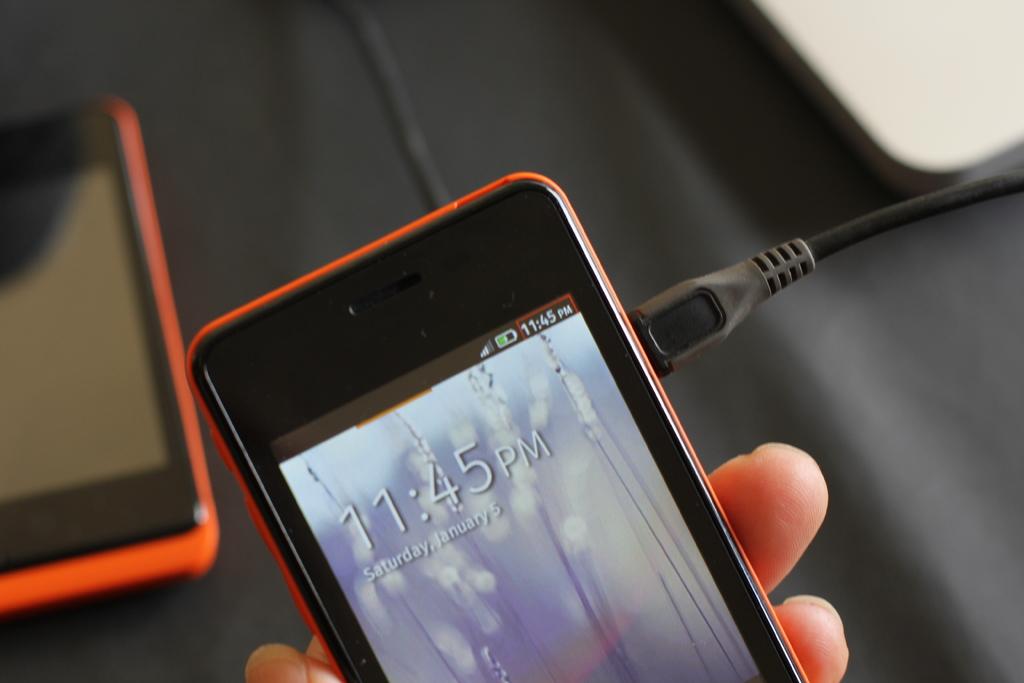What time does the cell phone say?
Your answer should be very brief. 11:45 pm. What day of the week is shown on the phone?
Ensure brevity in your answer.  Saturday. 